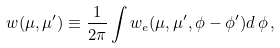<formula> <loc_0><loc_0><loc_500><loc_500>w ( \mu , \mu ^ { \prime } ) \equiv \frac { 1 } { 2 \pi } \int w _ { e } ( \mu , \mu ^ { \prime } , \phi - \phi ^ { \prime } ) d \, \phi \, ,</formula> 